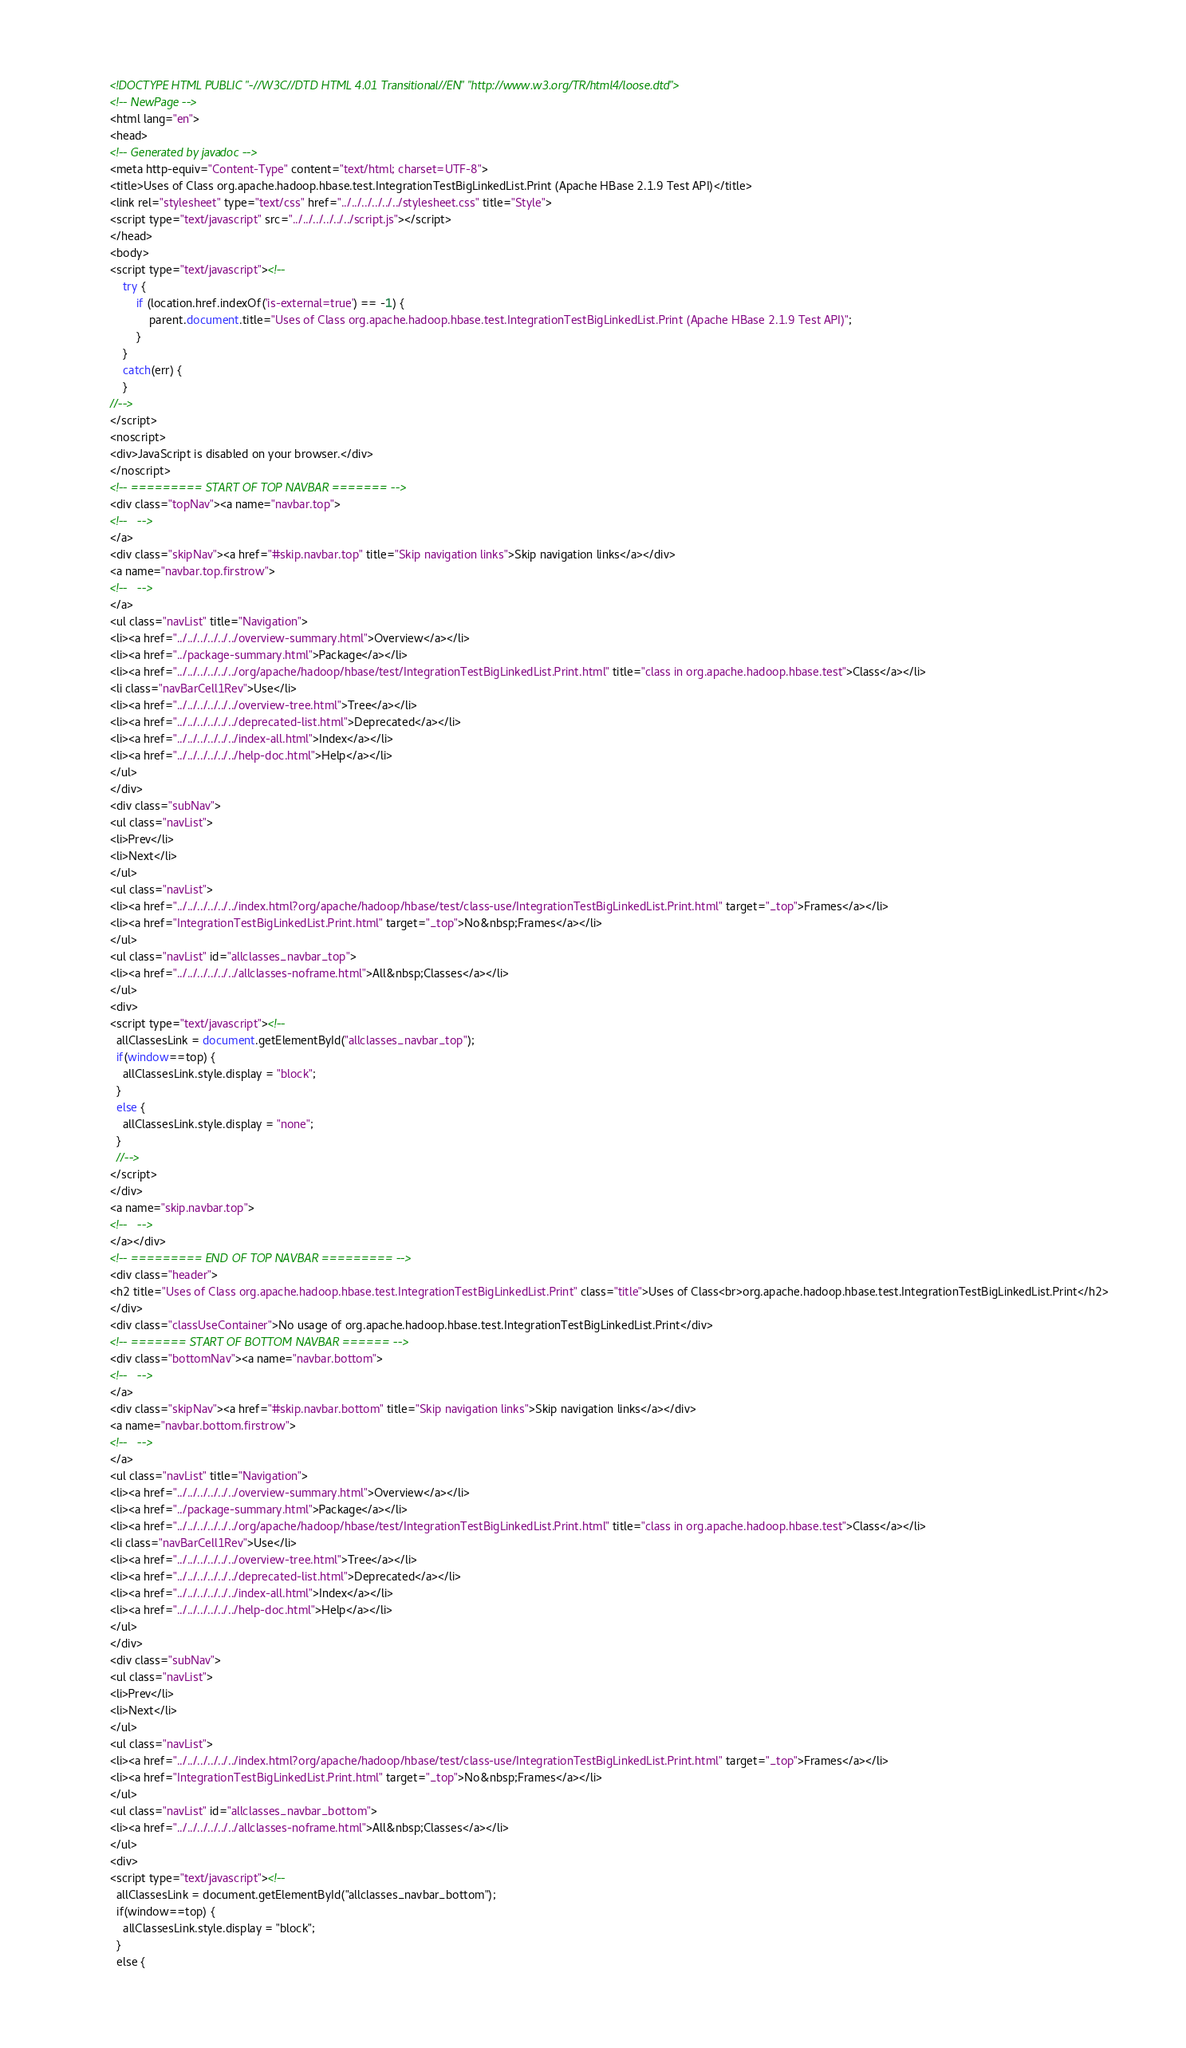Convert code to text. <code><loc_0><loc_0><loc_500><loc_500><_HTML_><!DOCTYPE HTML PUBLIC "-//W3C//DTD HTML 4.01 Transitional//EN" "http://www.w3.org/TR/html4/loose.dtd">
<!-- NewPage -->
<html lang="en">
<head>
<!-- Generated by javadoc -->
<meta http-equiv="Content-Type" content="text/html; charset=UTF-8">
<title>Uses of Class org.apache.hadoop.hbase.test.IntegrationTestBigLinkedList.Print (Apache HBase 2.1.9 Test API)</title>
<link rel="stylesheet" type="text/css" href="../../../../../../stylesheet.css" title="Style">
<script type="text/javascript" src="../../../../../../script.js"></script>
</head>
<body>
<script type="text/javascript"><!--
    try {
        if (location.href.indexOf('is-external=true') == -1) {
            parent.document.title="Uses of Class org.apache.hadoop.hbase.test.IntegrationTestBigLinkedList.Print (Apache HBase 2.1.9 Test API)";
        }
    }
    catch(err) {
    }
//-->
</script>
<noscript>
<div>JavaScript is disabled on your browser.</div>
</noscript>
<!-- ========= START OF TOP NAVBAR ======= -->
<div class="topNav"><a name="navbar.top">
<!--   -->
</a>
<div class="skipNav"><a href="#skip.navbar.top" title="Skip navigation links">Skip navigation links</a></div>
<a name="navbar.top.firstrow">
<!--   -->
</a>
<ul class="navList" title="Navigation">
<li><a href="../../../../../../overview-summary.html">Overview</a></li>
<li><a href="../package-summary.html">Package</a></li>
<li><a href="../../../../../../org/apache/hadoop/hbase/test/IntegrationTestBigLinkedList.Print.html" title="class in org.apache.hadoop.hbase.test">Class</a></li>
<li class="navBarCell1Rev">Use</li>
<li><a href="../../../../../../overview-tree.html">Tree</a></li>
<li><a href="../../../../../../deprecated-list.html">Deprecated</a></li>
<li><a href="../../../../../../index-all.html">Index</a></li>
<li><a href="../../../../../../help-doc.html">Help</a></li>
</ul>
</div>
<div class="subNav">
<ul class="navList">
<li>Prev</li>
<li>Next</li>
</ul>
<ul class="navList">
<li><a href="../../../../../../index.html?org/apache/hadoop/hbase/test/class-use/IntegrationTestBigLinkedList.Print.html" target="_top">Frames</a></li>
<li><a href="IntegrationTestBigLinkedList.Print.html" target="_top">No&nbsp;Frames</a></li>
</ul>
<ul class="navList" id="allclasses_navbar_top">
<li><a href="../../../../../../allclasses-noframe.html">All&nbsp;Classes</a></li>
</ul>
<div>
<script type="text/javascript"><!--
  allClassesLink = document.getElementById("allclasses_navbar_top");
  if(window==top) {
    allClassesLink.style.display = "block";
  }
  else {
    allClassesLink.style.display = "none";
  }
  //-->
</script>
</div>
<a name="skip.navbar.top">
<!--   -->
</a></div>
<!-- ========= END OF TOP NAVBAR ========= -->
<div class="header">
<h2 title="Uses of Class org.apache.hadoop.hbase.test.IntegrationTestBigLinkedList.Print" class="title">Uses of Class<br>org.apache.hadoop.hbase.test.IntegrationTestBigLinkedList.Print</h2>
</div>
<div class="classUseContainer">No usage of org.apache.hadoop.hbase.test.IntegrationTestBigLinkedList.Print</div>
<!-- ======= START OF BOTTOM NAVBAR ====== -->
<div class="bottomNav"><a name="navbar.bottom">
<!--   -->
</a>
<div class="skipNav"><a href="#skip.navbar.bottom" title="Skip navigation links">Skip navigation links</a></div>
<a name="navbar.bottom.firstrow">
<!--   -->
</a>
<ul class="navList" title="Navigation">
<li><a href="../../../../../../overview-summary.html">Overview</a></li>
<li><a href="../package-summary.html">Package</a></li>
<li><a href="../../../../../../org/apache/hadoop/hbase/test/IntegrationTestBigLinkedList.Print.html" title="class in org.apache.hadoop.hbase.test">Class</a></li>
<li class="navBarCell1Rev">Use</li>
<li><a href="../../../../../../overview-tree.html">Tree</a></li>
<li><a href="../../../../../../deprecated-list.html">Deprecated</a></li>
<li><a href="../../../../../../index-all.html">Index</a></li>
<li><a href="../../../../../../help-doc.html">Help</a></li>
</ul>
</div>
<div class="subNav">
<ul class="navList">
<li>Prev</li>
<li>Next</li>
</ul>
<ul class="navList">
<li><a href="../../../../../../index.html?org/apache/hadoop/hbase/test/class-use/IntegrationTestBigLinkedList.Print.html" target="_top">Frames</a></li>
<li><a href="IntegrationTestBigLinkedList.Print.html" target="_top">No&nbsp;Frames</a></li>
</ul>
<ul class="navList" id="allclasses_navbar_bottom">
<li><a href="../../../../../../allclasses-noframe.html">All&nbsp;Classes</a></li>
</ul>
<div>
<script type="text/javascript"><!--
  allClassesLink = document.getElementById("allclasses_navbar_bottom");
  if(window==top) {
    allClassesLink.style.display = "block";
  }
  else {</code> 